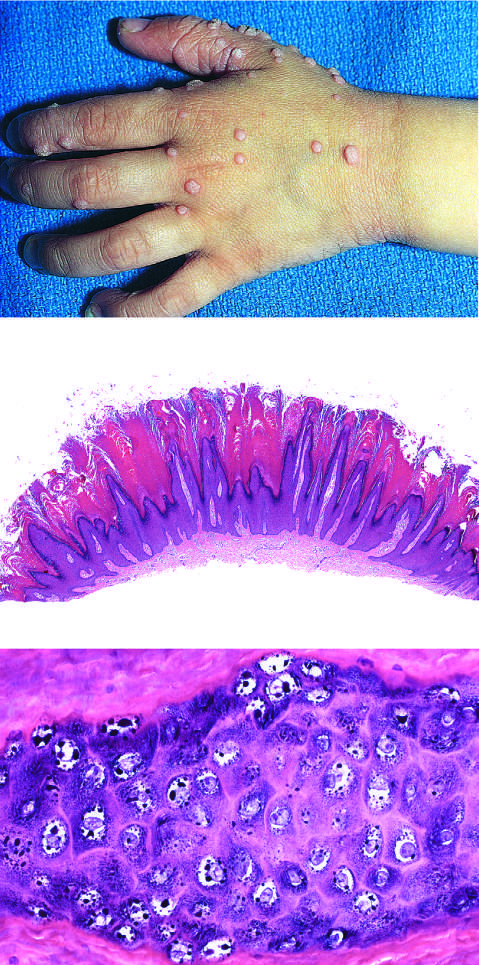do common warts contain zones of papillary epidermal proliferation that often radiate symmetrically like the points of a crown?
Answer the question using a single word or phrase. Yes 